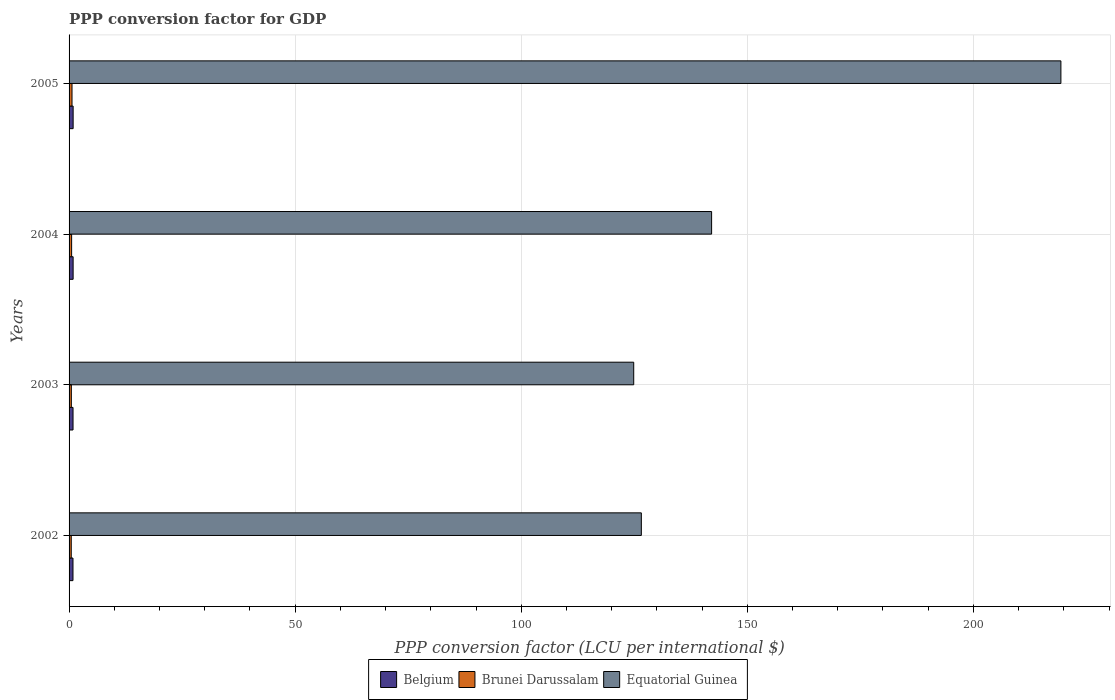How many groups of bars are there?
Ensure brevity in your answer.  4. Are the number of bars per tick equal to the number of legend labels?
Give a very brief answer. Yes. How many bars are there on the 2nd tick from the bottom?
Keep it short and to the point. 3. In how many cases, is the number of bars for a given year not equal to the number of legend labels?
Your answer should be compact. 0. What is the PPP conversion factor for GDP in Belgium in 2002?
Offer a very short reply. 0.87. Across all years, what is the maximum PPP conversion factor for GDP in Belgium?
Give a very brief answer. 0.9. Across all years, what is the minimum PPP conversion factor for GDP in Brunei Darussalam?
Keep it short and to the point. 0.48. In which year was the PPP conversion factor for GDP in Brunei Darussalam minimum?
Give a very brief answer. 2002. What is the total PPP conversion factor for GDP in Equatorial Guinea in the graph?
Your response must be concise. 612.91. What is the difference between the PPP conversion factor for GDP in Equatorial Guinea in 2003 and that in 2004?
Your answer should be very brief. -17.23. What is the difference between the PPP conversion factor for GDP in Equatorial Guinea in 2005 and the PPP conversion factor for GDP in Brunei Darussalam in 2002?
Your answer should be compact. 218.87. What is the average PPP conversion factor for GDP in Belgium per year?
Your response must be concise. 0.88. In the year 2005, what is the difference between the PPP conversion factor for GDP in Brunei Darussalam and PPP conversion factor for GDP in Belgium?
Give a very brief answer. -0.25. What is the ratio of the PPP conversion factor for GDP in Brunei Darussalam in 2002 to that in 2003?
Your response must be concise. 0.96. Is the PPP conversion factor for GDP in Brunei Darussalam in 2004 less than that in 2005?
Offer a very short reply. Yes. Is the difference between the PPP conversion factor for GDP in Brunei Darussalam in 2003 and 2004 greater than the difference between the PPP conversion factor for GDP in Belgium in 2003 and 2004?
Give a very brief answer. No. What is the difference between the highest and the second highest PPP conversion factor for GDP in Belgium?
Your answer should be very brief. 0. What is the difference between the highest and the lowest PPP conversion factor for GDP in Brunei Darussalam?
Your response must be concise. 0.17. What does the 1st bar from the top in 2005 represents?
Provide a succinct answer. Equatorial Guinea. What does the 1st bar from the bottom in 2005 represents?
Provide a succinct answer. Belgium. How many years are there in the graph?
Make the answer very short. 4. Does the graph contain grids?
Offer a very short reply. Yes. Where does the legend appear in the graph?
Provide a succinct answer. Bottom center. What is the title of the graph?
Offer a very short reply. PPP conversion factor for GDP. Does "Brunei Darussalam" appear as one of the legend labels in the graph?
Offer a terse response. Yes. What is the label or title of the X-axis?
Your response must be concise. PPP conversion factor (LCU per international $). What is the label or title of the Y-axis?
Your answer should be very brief. Years. What is the PPP conversion factor (LCU per international $) of Belgium in 2002?
Keep it short and to the point. 0.87. What is the PPP conversion factor (LCU per international $) of Brunei Darussalam in 2002?
Your answer should be compact. 0.48. What is the PPP conversion factor (LCU per international $) of Equatorial Guinea in 2002?
Give a very brief answer. 126.57. What is the PPP conversion factor (LCU per international $) in Belgium in 2003?
Ensure brevity in your answer.  0.88. What is the PPP conversion factor (LCU per international $) in Brunei Darussalam in 2003?
Offer a very short reply. 0.5. What is the PPP conversion factor (LCU per international $) in Equatorial Guinea in 2003?
Offer a very short reply. 124.88. What is the PPP conversion factor (LCU per international $) in Belgium in 2004?
Provide a short and direct response. 0.9. What is the PPP conversion factor (LCU per international $) of Brunei Darussalam in 2004?
Make the answer very short. 0.57. What is the PPP conversion factor (LCU per international $) in Equatorial Guinea in 2004?
Offer a very short reply. 142.1. What is the PPP conversion factor (LCU per international $) in Belgium in 2005?
Provide a succinct answer. 0.9. What is the PPP conversion factor (LCU per international $) of Brunei Darussalam in 2005?
Ensure brevity in your answer.  0.65. What is the PPP conversion factor (LCU per international $) of Equatorial Guinea in 2005?
Make the answer very short. 219.36. Across all years, what is the maximum PPP conversion factor (LCU per international $) in Belgium?
Your answer should be very brief. 0.9. Across all years, what is the maximum PPP conversion factor (LCU per international $) in Brunei Darussalam?
Offer a very short reply. 0.65. Across all years, what is the maximum PPP conversion factor (LCU per international $) of Equatorial Guinea?
Your answer should be compact. 219.36. Across all years, what is the minimum PPP conversion factor (LCU per international $) of Belgium?
Offer a terse response. 0.87. Across all years, what is the minimum PPP conversion factor (LCU per international $) in Brunei Darussalam?
Your response must be concise. 0.48. Across all years, what is the minimum PPP conversion factor (LCU per international $) of Equatorial Guinea?
Provide a succinct answer. 124.88. What is the total PPP conversion factor (LCU per international $) in Belgium in the graph?
Provide a succinct answer. 3.54. What is the total PPP conversion factor (LCU per international $) of Brunei Darussalam in the graph?
Give a very brief answer. 2.2. What is the total PPP conversion factor (LCU per international $) in Equatorial Guinea in the graph?
Give a very brief answer. 612.91. What is the difference between the PPP conversion factor (LCU per international $) in Belgium in 2002 and that in 2003?
Offer a very short reply. -0.01. What is the difference between the PPP conversion factor (LCU per international $) in Brunei Darussalam in 2002 and that in 2003?
Your answer should be compact. -0.02. What is the difference between the PPP conversion factor (LCU per international $) in Equatorial Guinea in 2002 and that in 2003?
Offer a terse response. 1.69. What is the difference between the PPP conversion factor (LCU per international $) in Belgium in 2002 and that in 2004?
Provide a short and direct response. -0.03. What is the difference between the PPP conversion factor (LCU per international $) in Brunei Darussalam in 2002 and that in 2004?
Give a very brief answer. -0.08. What is the difference between the PPP conversion factor (LCU per international $) in Equatorial Guinea in 2002 and that in 2004?
Ensure brevity in your answer.  -15.54. What is the difference between the PPP conversion factor (LCU per international $) in Belgium in 2002 and that in 2005?
Your response must be concise. -0.03. What is the difference between the PPP conversion factor (LCU per international $) in Brunei Darussalam in 2002 and that in 2005?
Your answer should be compact. -0.17. What is the difference between the PPP conversion factor (LCU per international $) of Equatorial Guinea in 2002 and that in 2005?
Ensure brevity in your answer.  -92.79. What is the difference between the PPP conversion factor (LCU per international $) of Belgium in 2003 and that in 2004?
Offer a very short reply. -0.02. What is the difference between the PPP conversion factor (LCU per international $) in Brunei Darussalam in 2003 and that in 2004?
Keep it short and to the point. -0.06. What is the difference between the PPP conversion factor (LCU per international $) of Equatorial Guinea in 2003 and that in 2004?
Your response must be concise. -17.23. What is the difference between the PPP conversion factor (LCU per international $) in Belgium in 2003 and that in 2005?
Keep it short and to the point. -0.02. What is the difference between the PPP conversion factor (LCU per international $) in Brunei Darussalam in 2003 and that in 2005?
Your answer should be compact. -0.15. What is the difference between the PPP conversion factor (LCU per international $) of Equatorial Guinea in 2003 and that in 2005?
Keep it short and to the point. -94.48. What is the difference between the PPP conversion factor (LCU per international $) in Belgium in 2004 and that in 2005?
Provide a succinct answer. -0. What is the difference between the PPP conversion factor (LCU per international $) in Brunei Darussalam in 2004 and that in 2005?
Your answer should be compact. -0.09. What is the difference between the PPP conversion factor (LCU per international $) of Equatorial Guinea in 2004 and that in 2005?
Your response must be concise. -77.25. What is the difference between the PPP conversion factor (LCU per international $) of Belgium in 2002 and the PPP conversion factor (LCU per international $) of Brunei Darussalam in 2003?
Offer a terse response. 0.36. What is the difference between the PPP conversion factor (LCU per international $) in Belgium in 2002 and the PPP conversion factor (LCU per international $) in Equatorial Guinea in 2003?
Provide a short and direct response. -124.01. What is the difference between the PPP conversion factor (LCU per international $) of Brunei Darussalam in 2002 and the PPP conversion factor (LCU per international $) of Equatorial Guinea in 2003?
Provide a short and direct response. -124.4. What is the difference between the PPP conversion factor (LCU per international $) in Belgium in 2002 and the PPP conversion factor (LCU per international $) in Brunei Darussalam in 2004?
Ensure brevity in your answer.  0.3. What is the difference between the PPP conversion factor (LCU per international $) of Belgium in 2002 and the PPP conversion factor (LCU per international $) of Equatorial Guinea in 2004?
Offer a very short reply. -141.24. What is the difference between the PPP conversion factor (LCU per international $) in Brunei Darussalam in 2002 and the PPP conversion factor (LCU per international $) in Equatorial Guinea in 2004?
Provide a succinct answer. -141.62. What is the difference between the PPP conversion factor (LCU per international $) in Belgium in 2002 and the PPP conversion factor (LCU per international $) in Brunei Darussalam in 2005?
Offer a terse response. 0.21. What is the difference between the PPP conversion factor (LCU per international $) in Belgium in 2002 and the PPP conversion factor (LCU per international $) in Equatorial Guinea in 2005?
Make the answer very short. -218.49. What is the difference between the PPP conversion factor (LCU per international $) of Brunei Darussalam in 2002 and the PPP conversion factor (LCU per international $) of Equatorial Guinea in 2005?
Provide a short and direct response. -218.87. What is the difference between the PPP conversion factor (LCU per international $) in Belgium in 2003 and the PPP conversion factor (LCU per international $) in Brunei Darussalam in 2004?
Ensure brevity in your answer.  0.31. What is the difference between the PPP conversion factor (LCU per international $) of Belgium in 2003 and the PPP conversion factor (LCU per international $) of Equatorial Guinea in 2004?
Provide a short and direct response. -141.23. What is the difference between the PPP conversion factor (LCU per international $) of Brunei Darussalam in 2003 and the PPP conversion factor (LCU per international $) of Equatorial Guinea in 2004?
Ensure brevity in your answer.  -141.6. What is the difference between the PPP conversion factor (LCU per international $) of Belgium in 2003 and the PPP conversion factor (LCU per international $) of Brunei Darussalam in 2005?
Ensure brevity in your answer.  0.23. What is the difference between the PPP conversion factor (LCU per international $) in Belgium in 2003 and the PPP conversion factor (LCU per international $) in Equatorial Guinea in 2005?
Provide a succinct answer. -218.48. What is the difference between the PPP conversion factor (LCU per international $) of Brunei Darussalam in 2003 and the PPP conversion factor (LCU per international $) of Equatorial Guinea in 2005?
Offer a terse response. -218.85. What is the difference between the PPP conversion factor (LCU per international $) of Belgium in 2004 and the PPP conversion factor (LCU per international $) of Brunei Darussalam in 2005?
Your answer should be compact. 0.25. What is the difference between the PPP conversion factor (LCU per international $) in Belgium in 2004 and the PPP conversion factor (LCU per international $) in Equatorial Guinea in 2005?
Ensure brevity in your answer.  -218.46. What is the difference between the PPP conversion factor (LCU per international $) in Brunei Darussalam in 2004 and the PPP conversion factor (LCU per international $) in Equatorial Guinea in 2005?
Offer a terse response. -218.79. What is the average PPP conversion factor (LCU per international $) in Belgium per year?
Ensure brevity in your answer.  0.88. What is the average PPP conversion factor (LCU per international $) in Brunei Darussalam per year?
Offer a terse response. 0.55. What is the average PPP conversion factor (LCU per international $) of Equatorial Guinea per year?
Provide a succinct answer. 153.23. In the year 2002, what is the difference between the PPP conversion factor (LCU per international $) in Belgium and PPP conversion factor (LCU per international $) in Brunei Darussalam?
Ensure brevity in your answer.  0.38. In the year 2002, what is the difference between the PPP conversion factor (LCU per international $) of Belgium and PPP conversion factor (LCU per international $) of Equatorial Guinea?
Offer a very short reply. -125.7. In the year 2002, what is the difference between the PPP conversion factor (LCU per international $) of Brunei Darussalam and PPP conversion factor (LCU per international $) of Equatorial Guinea?
Give a very brief answer. -126.08. In the year 2003, what is the difference between the PPP conversion factor (LCU per international $) of Belgium and PPP conversion factor (LCU per international $) of Brunei Darussalam?
Provide a short and direct response. 0.38. In the year 2003, what is the difference between the PPP conversion factor (LCU per international $) in Belgium and PPP conversion factor (LCU per international $) in Equatorial Guinea?
Give a very brief answer. -124. In the year 2003, what is the difference between the PPP conversion factor (LCU per international $) of Brunei Darussalam and PPP conversion factor (LCU per international $) of Equatorial Guinea?
Ensure brevity in your answer.  -124.38. In the year 2004, what is the difference between the PPP conversion factor (LCU per international $) in Belgium and PPP conversion factor (LCU per international $) in Brunei Darussalam?
Give a very brief answer. 0.33. In the year 2004, what is the difference between the PPP conversion factor (LCU per international $) of Belgium and PPP conversion factor (LCU per international $) of Equatorial Guinea?
Keep it short and to the point. -141.21. In the year 2004, what is the difference between the PPP conversion factor (LCU per international $) in Brunei Darussalam and PPP conversion factor (LCU per international $) in Equatorial Guinea?
Ensure brevity in your answer.  -141.54. In the year 2005, what is the difference between the PPP conversion factor (LCU per international $) in Belgium and PPP conversion factor (LCU per international $) in Brunei Darussalam?
Make the answer very short. 0.25. In the year 2005, what is the difference between the PPP conversion factor (LCU per international $) in Belgium and PPP conversion factor (LCU per international $) in Equatorial Guinea?
Offer a terse response. -218.46. In the year 2005, what is the difference between the PPP conversion factor (LCU per international $) in Brunei Darussalam and PPP conversion factor (LCU per international $) in Equatorial Guinea?
Make the answer very short. -218.71. What is the ratio of the PPP conversion factor (LCU per international $) of Belgium in 2002 to that in 2003?
Ensure brevity in your answer.  0.99. What is the ratio of the PPP conversion factor (LCU per international $) of Brunei Darussalam in 2002 to that in 2003?
Your answer should be compact. 0.96. What is the ratio of the PPP conversion factor (LCU per international $) in Equatorial Guinea in 2002 to that in 2003?
Offer a very short reply. 1.01. What is the ratio of the PPP conversion factor (LCU per international $) of Belgium in 2002 to that in 2004?
Your response must be concise. 0.97. What is the ratio of the PPP conversion factor (LCU per international $) of Brunei Darussalam in 2002 to that in 2004?
Ensure brevity in your answer.  0.85. What is the ratio of the PPP conversion factor (LCU per international $) in Equatorial Guinea in 2002 to that in 2004?
Offer a very short reply. 0.89. What is the ratio of the PPP conversion factor (LCU per international $) of Belgium in 2002 to that in 2005?
Your answer should be very brief. 0.96. What is the ratio of the PPP conversion factor (LCU per international $) of Brunei Darussalam in 2002 to that in 2005?
Your answer should be compact. 0.74. What is the ratio of the PPP conversion factor (LCU per international $) of Equatorial Guinea in 2002 to that in 2005?
Provide a short and direct response. 0.58. What is the ratio of the PPP conversion factor (LCU per international $) of Belgium in 2003 to that in 2004?
Offer a terse response. 0.98. What is the ratio of the PPP conversion factor (LCU per international $) of Brunei Darussalam in 2003 to that in 2004?
Give a very brief answer. 0.89. What is the ratio of the PPP conversion factor (LCU per international $) in Equatorial Guinea in 2003 to that in 2004?
Provide a short and direct response. 0.88. What is the ratio of the PPP conversion factor (LCU per international $) in Belgium in 2003 to that in 2005?
Give a very brief answer. 0.98. What is the ratio of the PPP conversion factor (LCU per international $) of Brunei Darussalam in 2003 to that in 2005?
Ensure brevity in your answer.  0.77. What is the ratio of the PPP conversion factor (LCU per international $) in Equatorial Guinea in 2003 to that in 2005?
Offer a very short reply. 0.57. What is the ratio of the PPP conversion factor (LCU per international $) of Belgium in 2004 to that in 2005?
Give a very brief answer. 1. What is the ratio of the PPP conversion factor (LCU per international $) in Brunei Darussalam in 2004 to that in 2005?
Keep it short and to the point. 0.87. What is the ratio of the PPP conversion factor (LCU per international $) of Equatorial Guinea in 2004 to that in 2005?
Your answer should be compact. 0.65. What is the difference between the highest and the second highest PPP conversion factor (LCU per international $) in Belgium?
Keep it short and to the point. 0. What is the difference between the highest and the second highest PPP conversion factor (LCU per international $) in Brunei Darussalam?
Provide a succinct answer. 0.09. What is the difference between the highest and the second highest PPP conversion factor (LCU per international $) in Equatorial Guinea?
Give a very brief answer. 77.25. What is the difference between the highest and the lowest PPP conversion factor (LCU per international $) in Belgium?
Give a very brief answer. 0.03. What is the difference between the highest and the lowest PPP conversion factor (LCU per international $) of Brunei Darussalam?
Your answer should be very brief. 0.17. What is the difference between the highest and the lowest PPP conversion factor (LCU per international $) of Equatorial Guinea?
Provide a short and direct response. 94.48. 